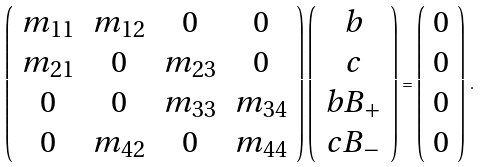<formula> <loc_0><loc_0><loc_500><loc_500>\left ( \begin{array} { c c c c } m _ { 1 1 } & m _ { 1 2 } & 0 & 0 \\ m _ { 2 1 } & 0 & m _ { 2 3 } & 0 \\ 0 & 0 & m _ { 3 3 } & m _ { 3 4 } \\ 0 & m _ { 4 2 } & 0 & m _ { 4 4 } \end{array} \right ) \left ( \begin{array} { c } b \\ c \\ b B _ { + } \\ c B _ { - } \end{array} \right ) = \left ( \begin{array} { c } 0 \\ 0 \\ 0 \\ 0 \end{array} \right ) \, .</formula> 